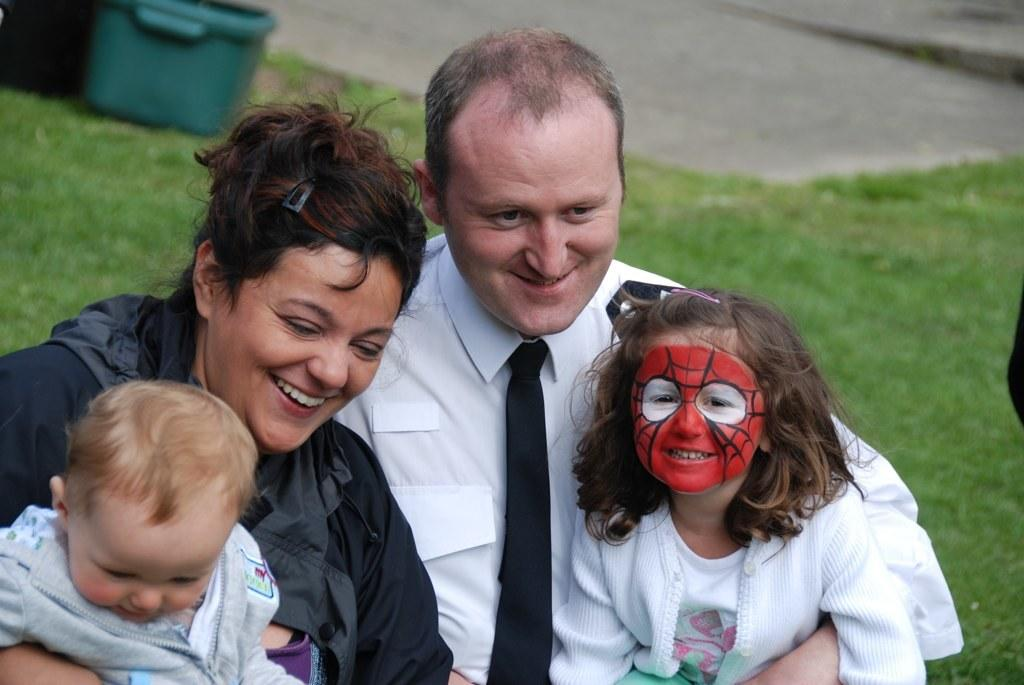How many people are present in the image? There are four people in the image: a man, a lady, a kid, and a girl wearing a mask. What is the girl wearing in the image? The girl is wearing a mask in the image. What can be seen in the background of the image? There is ground visible in the background of the image. What finger does the achiever use to point in the image? There is no achiever present in the image, and therefore no finger or pointing can be observed. 